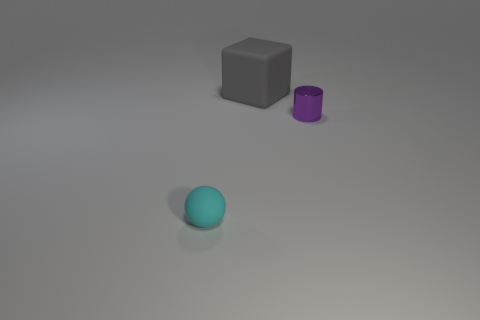How many objects are tiny cyan spheres or small things behind the matte ball?
Offer a terse response. 2. What size is the object to the right of the large gray matte block?
Provide a short and direct response. Small. Do the small cyan ball and the object behind the purple metallic thing have the same material?
Provide a short and direct response. Yes. There is a small thing behind the object that is in front of the metal cylinder; how many cyan rubber objects are on the left side of it?
Provide a succinct answer. 1. What number of yellow objects are big matte cylinders or tiny things?
Your answer should be very brief. 0. There is a small object that is right of the tiny cyan rubber thing; what shape is it?
Provide a succinct answer. Cylinder. What is the color of the metal cylinder that is the same size as the cyan object?
Offer a very short reply. Purple. What material is the object on the right side of the matte thing behind the matte object to the left of the large gray rubber cube made of?
Make the answer very short. Metal. What number of small things are either gray things or blue objects?
Provide a short and direct response. 0. How many other things are there of the same size as the gray rubber block?
Provide a short and direct response. 0. 